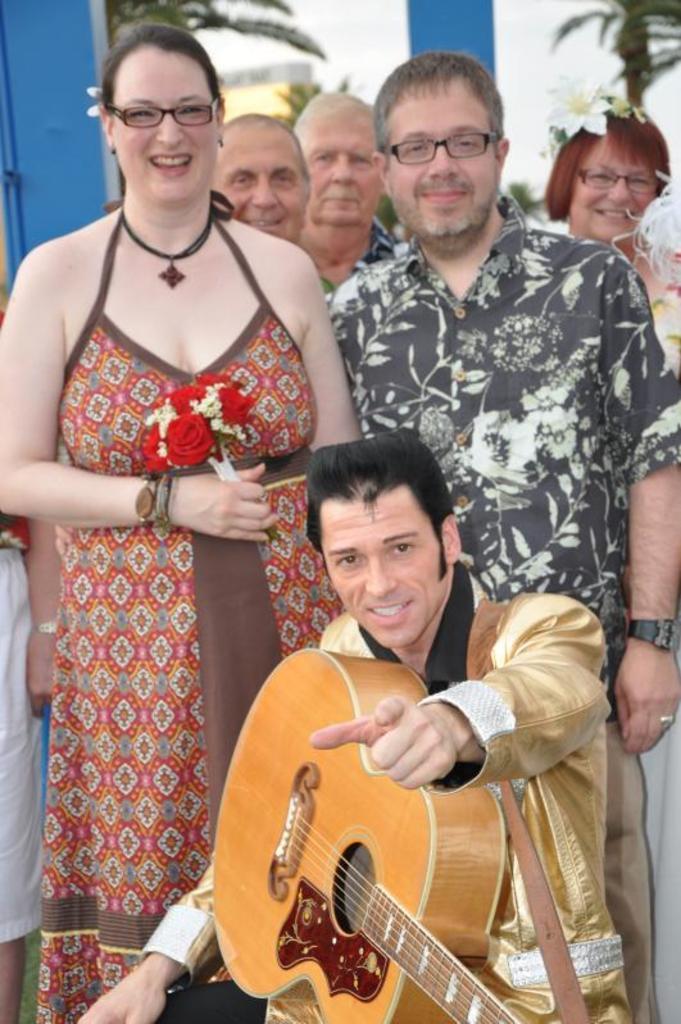Could you give a brief overview of what you see in this image? There are so many people standing and one person sitting holding a guitar in his hand. 